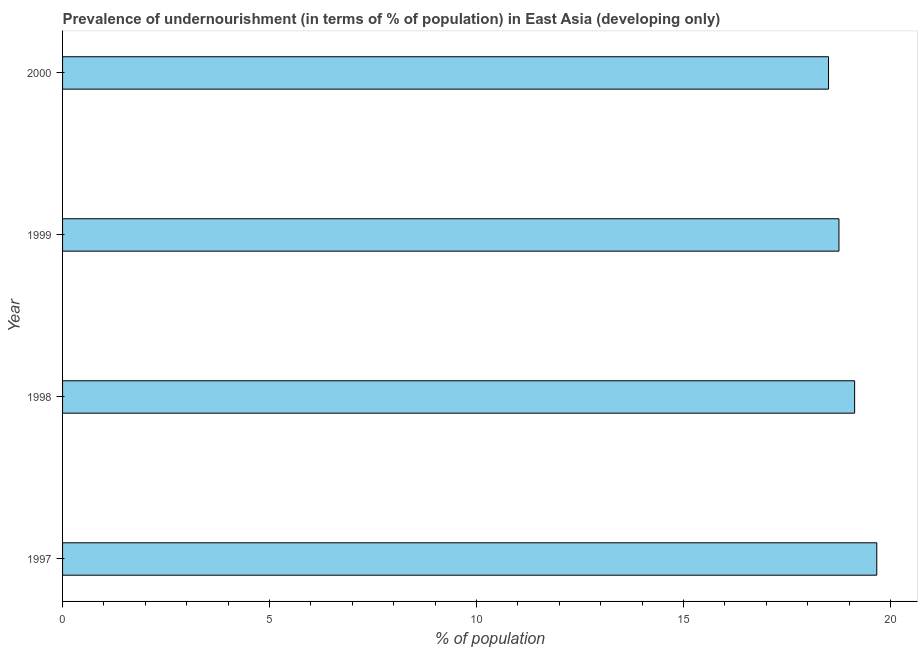What is the title of the graph?
Keep it short and to the point. Prevalence of undernourishment (in terms of % of population) in East Asia (developing only). What is the label or title of the X-axis?
Your answer should be very brief. % of population. What is the label or title of the Y-axis?
Make the answer very short. Year. What is the percentage of undernourished population in 1997?
Make the answer very short. 19.67. Across all years, what is the maximum percentage of undernourished population?
Your response must be concise. 19.67. Across all years, what is the minimum percentage of undernourished population?
Your answer should be very brief. 18.51. In which year was the percentage of undernourished population maximum?
Offer a terse response. 1997. In which year was the percentage of undernourished population minimum?
Give a very brief answer. 2000. What is the sum of the percentage of undernourished population?
Your response must be concise. 76.07. What is the difference between the percentage of undernourished population in 1997 and 1999?
Your answer should be very brief. 0.91. What is the average percentage of undernourished population per year?
Offer a very short reply. 19.02. What is the median percentage of undernourished population?
Keep it short and to the point. 18.95. In how many years, is the percentage of undernourished population greater than 10 %?
Provide a short and direct response. 4. What is the ratio of the percentage of undernourished population in 1998 to that in 2000?
Keep it short and to the point. 1.03. What is the difference between the highest and the second highest percentage of undernourished population?
Give a very brief answer. 0.54. Is the sum of the percentage of undernourished population in 1998 and 1999 greater than the maximum percentage of undernourished population across all years?
Give a very brief answer. Yes. What is the difference between the highest and the lowest percentage of undernourished population?
Provide a succinct answer. 1.17. In how many years, is the percentage of undernourished population greater than the average percentage of undernourished population taken over all years?
Your answer should be very brief. 2. How many years are there in the graph?
Give a very brief answer. 4. Are the values on the major ticks of X-axis written in scientific E-notation?
Offer a very short reply. No. What is the % of population in 1997?
Keep it short and to the point. 19.67. What is the % of population in 1998?
Make the answer very short. 19.14. What is the % of population of 1999?
Ensure brevity in your answer.  18.76. What is the % of population in 2000?
Ensure brevity in your answer.  18.51. What is the difference between the % of population in 1997 and 1998?
Offer a terse response. 0.54. What is the difference between the % of population in 1997 and 1999?
Your response must be concise. 0.91. What is the difference between the % of population in 1997 and 2000?
Keep it short and to the point. 1.17. What is the difference between the % of population in 1998 and 1999?
Make the answer very short. 0.38. What is the difference between the % of population in 1998 and 2000?
Provide a short and direct response. 0.63. What is the difference between the % of population in 1999 and 2000?
Offer a terse response. 0.25. What is the ratio of the % of population in 1997 to that in 1998?
Keep it short and to the point. 1.03. What is the ratio of the % of population in 1997 to that in 1999?
Provide a short and direct response. 1.05. What is the ratio of the % of population in 1997 to that in 2000?
Your response must be concise. 1.06. What is the ratio of the % of population in 1998 to that in 1999?
Offer a terse response. 1.02. What is the ratio of the % of population in 1998 to that in 2000?
Your response must be concise. 1.03. 